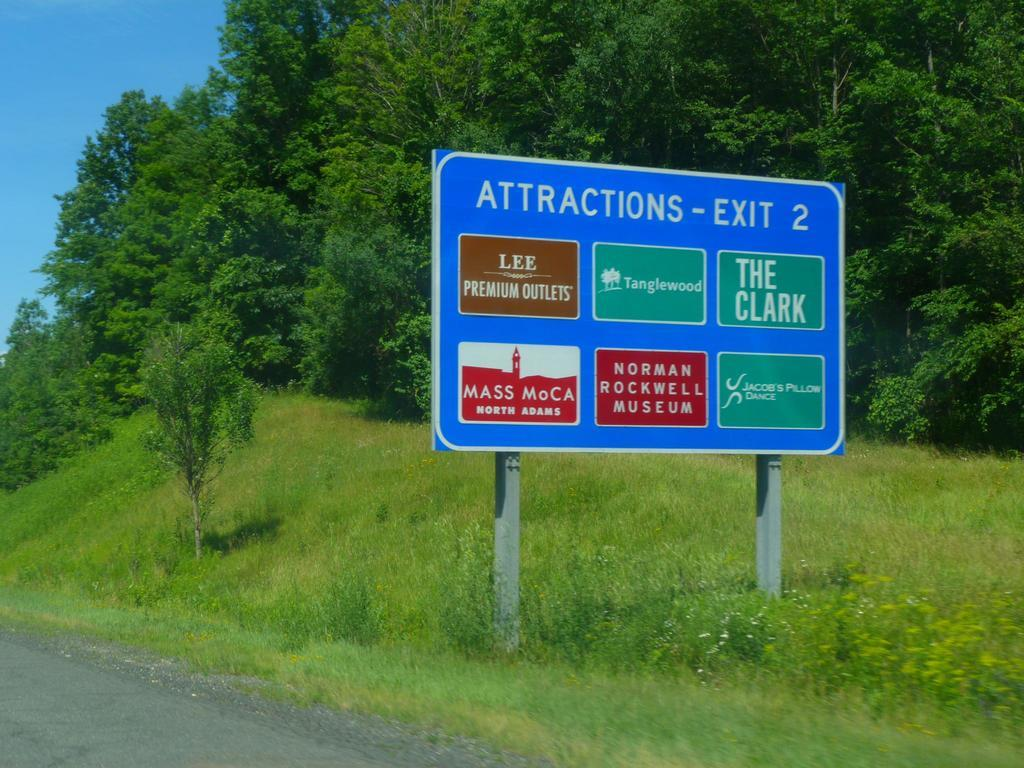Provide a one-sentence caption for the provided image. A highway sign lists the attractions located off exit 2. 